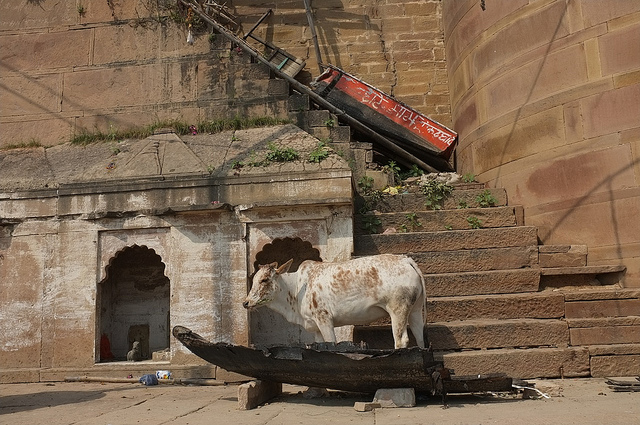What might be the reason for the cow being on the boat? The cow could be on the boat either by accident or as part of a local custom or event. It's an unusual situation that might have cultural or practical explanations. 